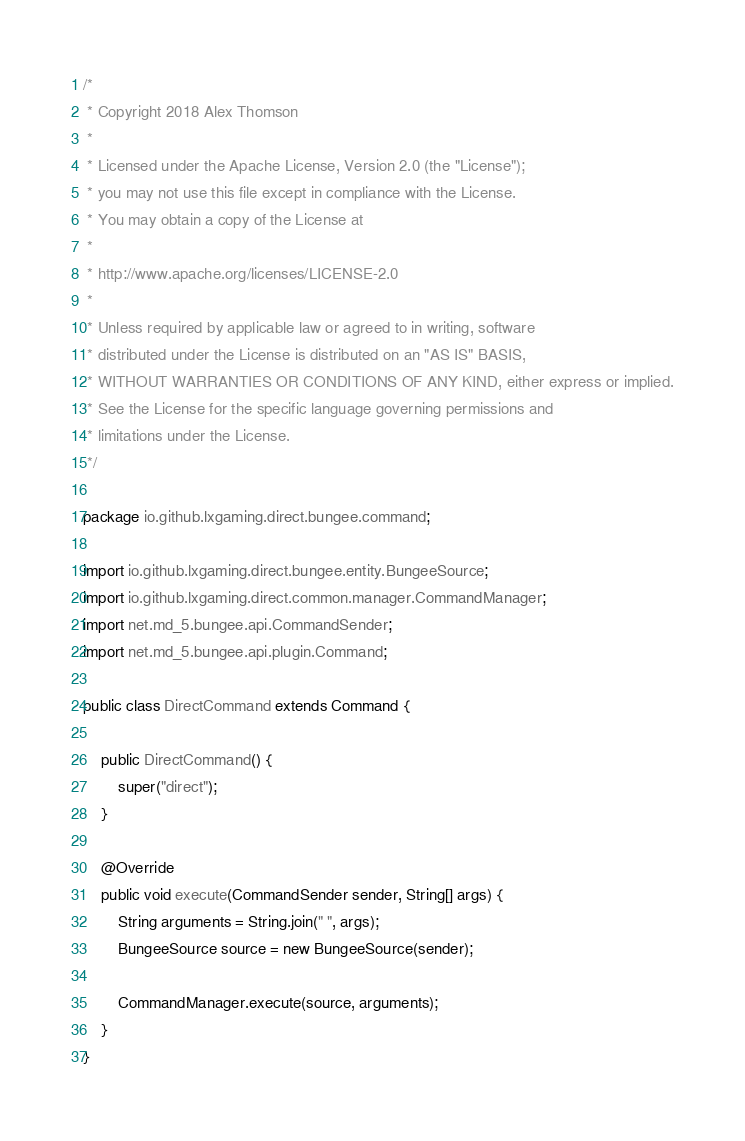<code> <loc_0><loc_0><loc_500><loc_500><_Java_>/*
 * Copyright 2018 Alex Thomson
 *
 * Licensed under the Apache License, Version 2.0 (the "License");
 * you may not use this file except in compliance with the License.
 * You may obtain a copy of the License at
 *
 * http://www.apache.org/licenses/LICENSE-2.0
 *
 * Unless required by applicable law or agreed to in writing, software
 * distributed under the License is distributed on an "AS IS" BASIS,
 * WITHOUT WARRANTIES OR CONDITIONS OF ANY KIND, either express or implied.
 * See the License for the specific language governing permissions and
 * limitations under the License.
 */

package io.github.lxgaming.direct.bungee.command;

import io.github.lxgaming.direct.bungee.entity.BungeeSource;
import io.github.lxgaming.direct.common.manager.CommandManager;
import net.md_5.bungee.api.CommandSender;
import net.md_5.bungee.api.plugin.Command;

public class DirectCommand extends Command {
    
    public DirectCommand() {
        super("direct");
    }
    
    @Override
    public void execute(CommandSender sender, String[] args) {
        String arguments = String.join(" ", args);
        BungeeSource source = new BungeeSource(sender);
        
        CommandManager.execute(source, arguments);
    }
}</code> 